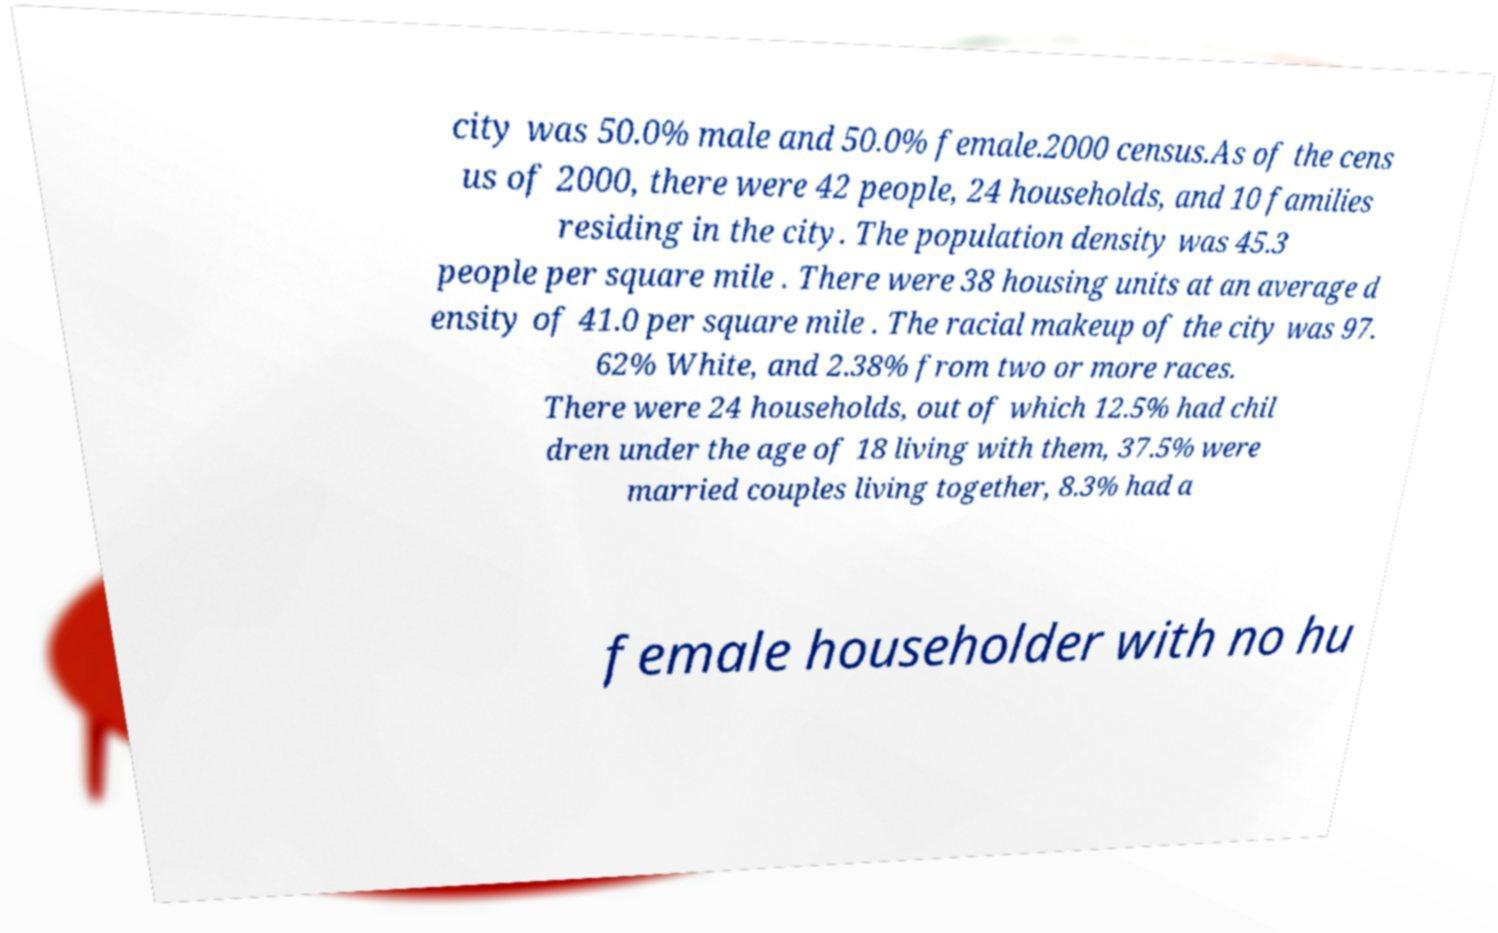Could you extract and type out the text from this image? city was 50.0% male and 50.0% female.2000 census.As of the cens us of 2000, there were 42 people, 24 households, and 10 families residing in the city. The population density was 45.3 people per square mile . There were 38 housing units at an average d ensity of 41.0 per square mile . The racial makeup of the city was 97. 62% White, and 2.38% from two or more races. There were 24 households, out of which 12.5% had chil dren under the age of 18 living with them, 37.5% were married couples living together, 8.3% had a female householder with no hu 